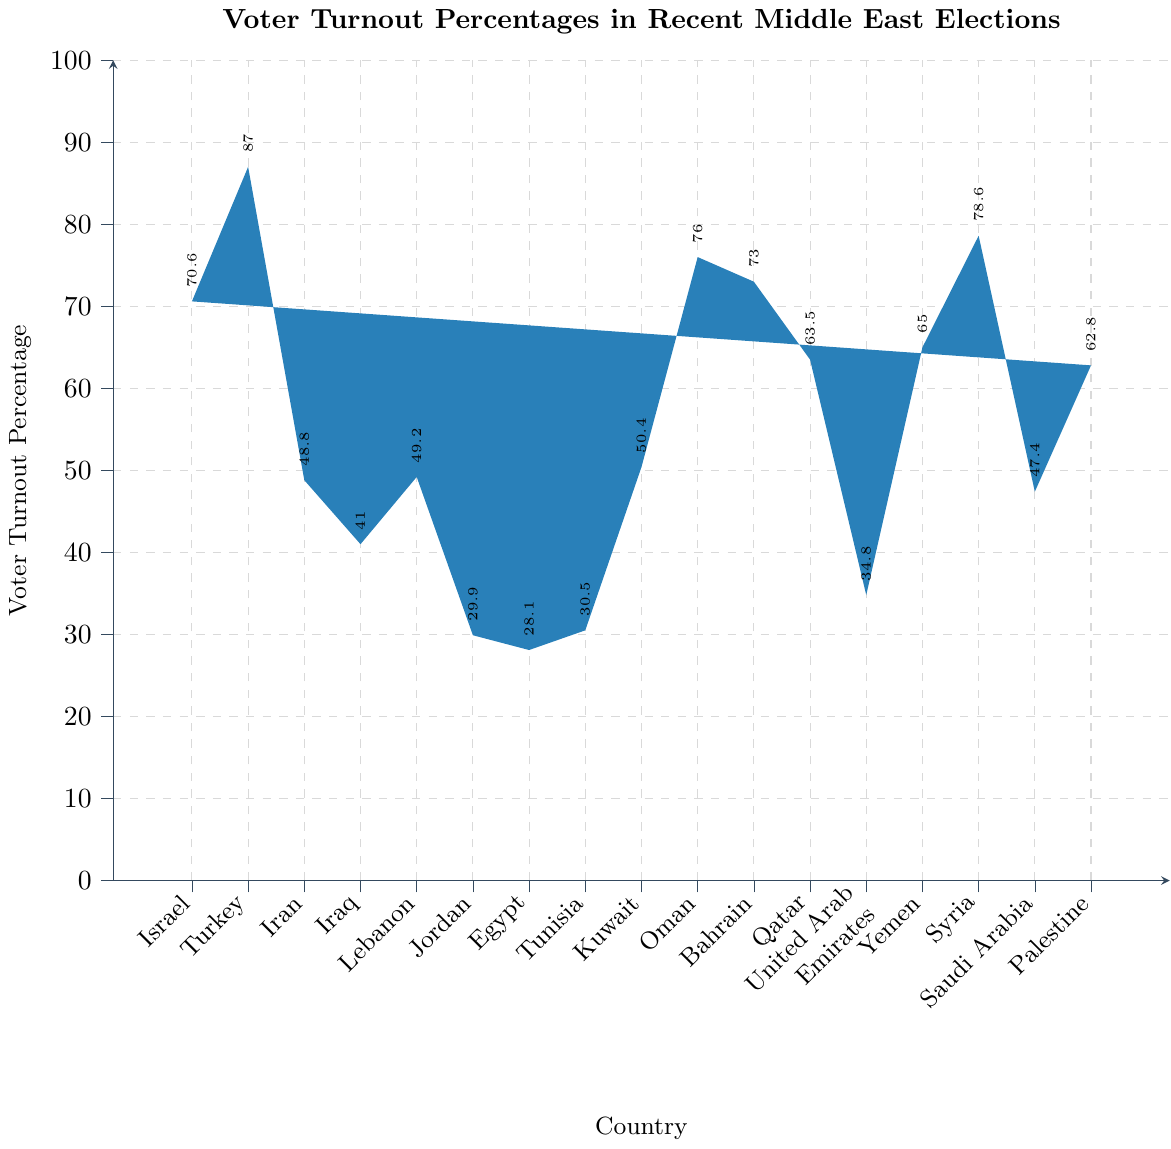What country had the highest voter turnout percentage? Look at the bar representing each country and identify the one with the tallest bar. Turkey has the highest bar, indicating the highest voter turnout percentage.
Answer: Turkey Which countries had voter turnout percentages above 70%? Identify the bars that reach above the 70% mark on the y-axis, then note the corresponding countries: Israel, Oman, Bahrain, Yemen, and Syria are all above 70%.
Answer: Israel, Oman, Bahrain, Yemen, Syria What is the difference in voter turnout percentage between the country with the highest turnout and the country with the lowest turnout? Turkey has the highest turnout (87.0%) and Egypt has the lowest turnout (28.1%). Calculate the difference: 87.0% - 28.1% = 58.9%.
Answer: 58.9% Which country has a higher voter turnout, Palestine or Qatar? Compare the heights of the bars for Palestine and Qatar. Palestine's bar is slightly lower than Qatar's.
Answer: Qatar What is the average voter turnout percentage across all the countries? Add all the voter turnout percentages and divide by the number of countries. 
(70.6 + 87.0 + 48.8 + 41.0 + 49.2 + 29.9 + 28.1 + 30.5 + 50.4 + 76.0 + 73.0 + 63.5 + 34.8 + 65.0 + 78.6 + 47.4 + 62.8) / 17 = 55.44%
Answer: 55.44% Which country has a voter turnout percentage closest to 50%? Look for the bar that is closest to the 50% mark on the y-axis. Kuwait has a voter turnout of 50.4%, which is the closest to 50%.
Answer: Kuwait What is the median voter turnout percentage? Arrange the voter turnout percentages in ascending order and find the middle value.
28.1, 29.9, 30.5, 34.8, 41.0, 47.4, 48.8, 49.2, 50.4, 62.8, 63.5, 65.0, 70.6, 73.0, 76.0, 78.6, 87.0 
The median is the 9th value, which is 50.4%.
Answer: 50.4% Which country's voter turnout percentage falls below 40%? Identify bars that do not reach the 40% mark on the y-axis. Only Jordan and Egypt have bars below 40%.
Answer: Jordan, Egypt What is the sum of the voter turnout percentages for Israel and Syria? Add the voter turnout percentages of Israel (70.6%) and Syria (78.6%).
70.6% + 78.6% = 149.2%.
Answer: 149.2% 